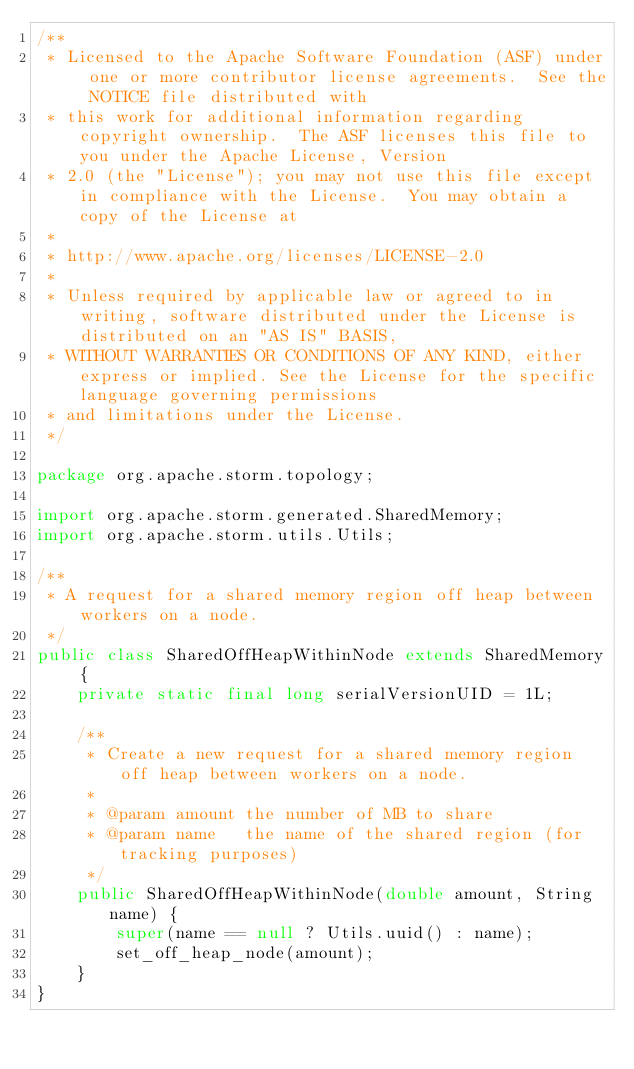<code> <loc_0><loc_0><loc_500><loc_500><_Java_>/**
 * Licensed to the Apache Software Foundation (ASF) under one or more contributor license agreements.  See the NOTICE file distributed with
 * this work for additional information regarding copyright ownership.  The ASF licenses this file to you under the Apache License, Version
 * 2.0 (the "License"); you may not use this file except in compliance with the License.  You may obtain a copy of the License at
 *
 * http://www.apache.org/licenses/LICENSE-2.0
 *
 * Unless required by applicable law or agreed to in writing, software distributed under the License is distributed on an "AS IS" BASIS,
 * WITHOUT WARRANTIES OR CONDITIONS OF ANY KIND, either express or implied. See the License for the specific language governing permissions
 * and limitations under the License.
 */

package org.apache.storm.topology;

import org.apache.storm.generated.SharedMemory;
import org.apache.storm.utils.Utils;

/**
 * A request for a shared memory region off heap between workers on a node.
 */
public class SharedOffHeapWithinNode extends SharedMemory {
    private static final long serialVersionUID = 1L;

    /**
     * Create a new request for a shared memory region off heap between workers on a node.
     *
     * @param amount the number of MB to share
     * @param name   the name of the shared region (for tracking purposes)
     */
    public SharedOffHeapWithinNode(double amount, String name) {
        super(name == null ? Utils.uuid() : name);
        set_off_heap_node(amount);
    }
}
</code> 